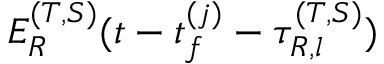Convert formula to latex. <formula><loc_0><loc_0><loc_500><loc_500>E _ { R } ^ { ( T , S ) } ( t - t _ { f } ^ { ( j ) } - \tau _ { R , l } ^ { ( T , S ) } )</formula> 